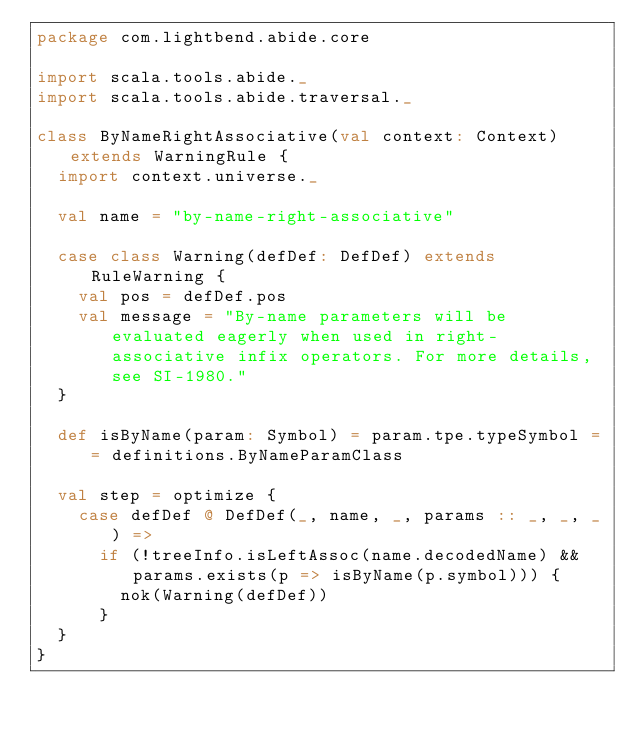<code> <loc_0><loc_0><loc_500><loc_500><_Scala_>package com.lightbend.abide.core

import scala.tools.abide._
import scala.tools.abide.traversal._

class ByNameRightAssociative(val context: Context) extends WarningRule {
  import context.universe._

  val name = "by-name-right-associative"

  case class Warning(defDef: DefDef) extends RuleWarning {
    val pos = defDef.pos
    val message = "By-name parameters will be evaluated eagerly when used in right-associative infix operators. For more details, see SI-1980."
  }

  def isByName(param: Symbol) = param.tpe.typeSymbol == definitions.ByNameParamClass

  val step = optimize {
    case defDef @ DefDef(_, name, _, params :: _, _, _) =>
      if (!treeInfo.isLeftAssoc(name.decodedName) && params.exists(p => isByName(p.symbol))) {
        nok(Warning(defDef))
      }
  }
}
</code> 